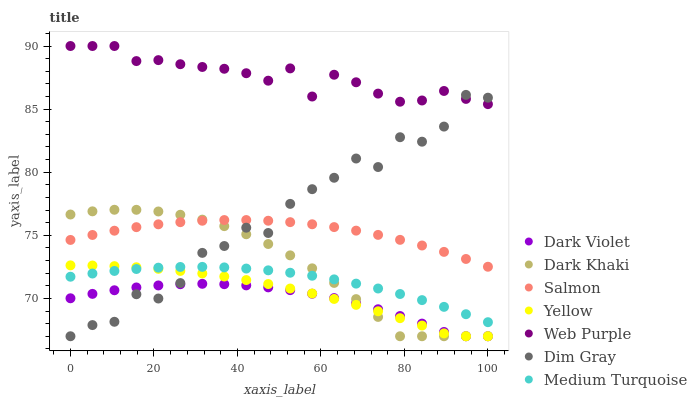Does Dark Violet have the minimum area under the curve?
Answer yes or no. Yes. Does Web Purple have the maximum area under the curve?
Answer yes or no. Yes. Does Salmon have the minimum area under the curve?
Answer yes or no. No. Does Salmon have the maximum area under the curve?
Answer yes or no. No. Is Medium Turquoise the smoothest?
Answer yes or no. Yes. Is Dim Gray the roughest?
Answer yes or no. Yes. Is Salmon the smoothest?
Answer yes or no. No. Is Salmon the roughest?
Answer yes or no. No. Does Dim Gray have the lowest value?
Answer yes or no. Yes. Does Salmon have the lowest value?
Answer yes or no. No. Does Web Purple have the highest value?
Answer yes or no. Yes. Does Salmon have the highest value?
Answer yes or no. No. Is Yellow less than Salmon?
Answer yes or no. Yes. Is Web Purple greater than Medium Turquoise?
Answer yes or no. Yes. Does Dark Khaki intersect Salmon?
Answer yes or no. Yes. Is Dark Khaki less than Salmon?
Answer yes or no. No. Is Dark Khaki greater than Salmon?
Answer yes or no. No. Does Yellow intersect Salmon?
Answer yes or no. No. 